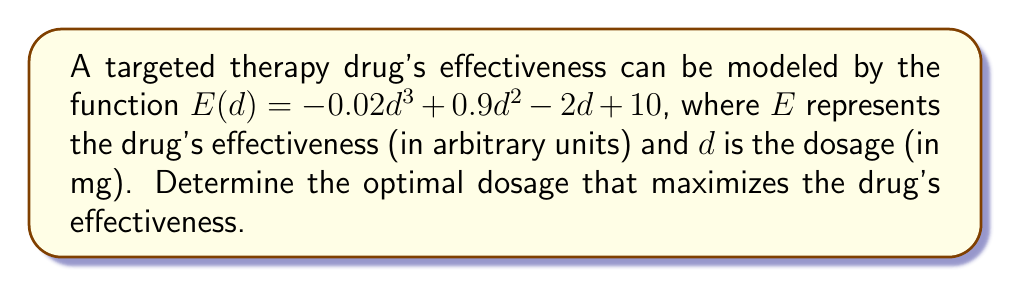Could you help me with this problem? To find the optimal dosage that maximizes the drug's effectiveness, we need to find the maximum point of the function $E(d)$. This can be done by following these steps:

1. Find the derivative of $E(d)$ with respect to $d$:
   $$E'(d) = -0.06d^2 + 1.8d - 2$$

2. Set the derivative equal to zero to find critical points:
   $$-0.06d^2 + 1.8d - 2 = 0$$

3. Solve the quadratic equation:
   $$-0.06(d^2 - 30d + 33.33) = 0$$
   $$d^2 - 30d + 33.33 = 0$$
   
   Using the quadratic formula: $d = \frac{-b \pm \sqrt{b^2 - 4ac}}{2a}$
   
   $$d = \frac{30 \pm \sqrt{900 - 133.32}}{2} = \frac{30 \pm \sqrt{766.68}}{2}$$
   
   $$d \approx 26.67 \text{ or } 3.33$$

4. To determine which critical point gives the maximum effectiveness, we can use the second derivative test:
   $$E''(d) = -0.12d + 1.8$$
   
   At $d = 26.67$: $E''(26.67) \approx -1.4 < 0$, indicating a local maximum
   At $d = 3.33$: $E''(3.33) \approx 1.4 > 0$, indicating a local minimum

5. Therefore, the optimal dosage that maximizes the drug's effectiveness is approximately 26.67 mg.
Answer: 26.67 mg 